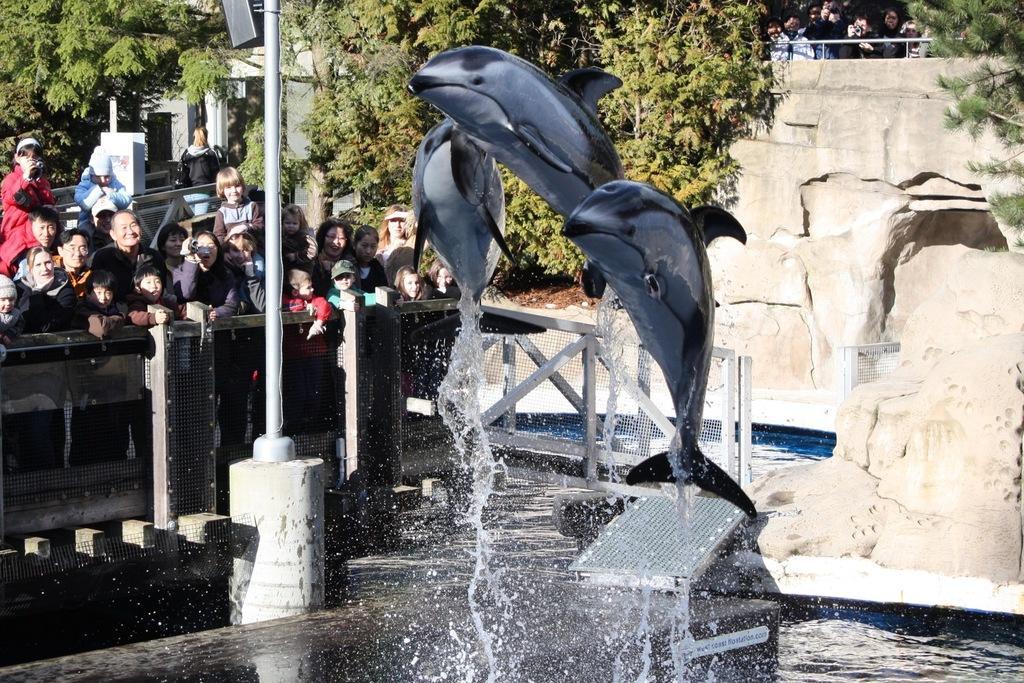Could you give a brief overview of what you see in this image? In the picture we can see a dolphin from the water flying and besides to it, we can see a pole and some people standing near the railing and we can also see a rock wall and some plants and trees and in the background we can see a building with pillars. 